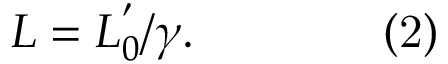<formula> <loc_0><loc_0><loc_500><loc_500>L = L _ { 0 } ^ { ^ { \prime } } / \gamma . \quad { ( 2 ) }</formula> 